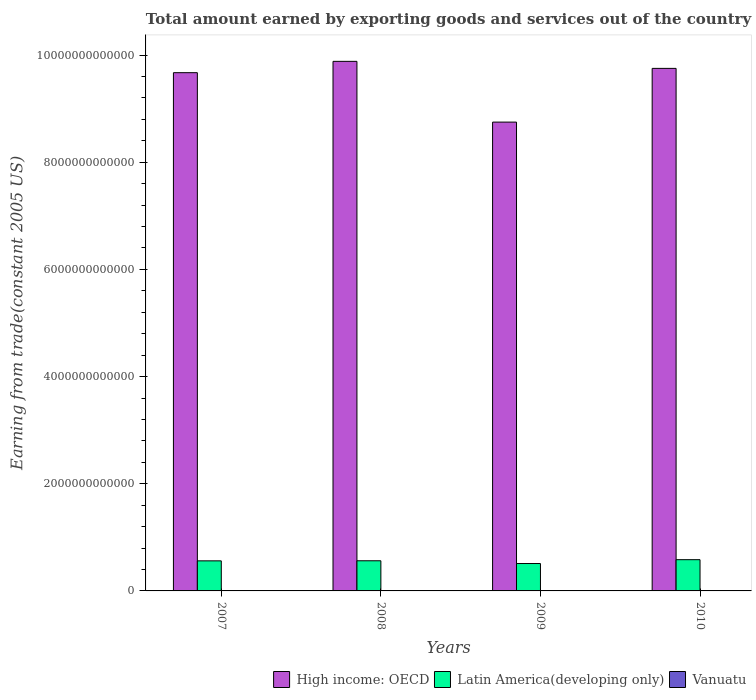How many different coloured bars are there?
Keep it short and to the point. 3. How many groups of bars are there?
Offer a very short reply. 4. Are the number of bars on each tick of the X-axis equal?
Give a very brief answer. Yes. How many bars are there on the 3rd tick from the right?
Provide a succinct answer. 3. What is the total amount earned by exporting goods and services in High income: OECD in 2007?
Offer a terse response. 9.67e+12. Across all years, what is the maximum total amount earned by exporting goods and services in Latin America(developing only)?
Ensure brevity in your answer.  5.83e+11. Across all years, what is the minimum total amount earned by exporting goods and services in High income: OECD?
Offer a very short reply. 8.75e+12. In which year was the total amount earned by exporting goods and services in High income: OECD minimum?
Your answer should be very brief. 2009. What is the total total amount earned by exporting goods and services in Latin America(developing only) in the graph?
Offer a very short reply. 2.22e+12. What is the difference between the total amount earned by exporting goods and services in High income: OECD in 2007 and that in 2008?
Your answer should be compact. -2.11e+11. What is the difference between the total amount earned by exporting goods and services in Latin America(developing only) in 2008 and the total amount earned by exporting goods and services in Vanuatu in 2010?
Offer a very short reply. 5.62e+11. What is the average total amount earned by exporting goods and services in Latin America(developing only) per year?
Keep it short and to the point. 5.55e+11. In the year 2007, what is the difference between the total amount earned by exporting goods and services in Vanuatu and total amount earned by exporting goods and services in Latin America(developing only)?
Your response must be concise. -5.61e+11. In how many years, is the total amount earned by exporting goods and services in Latin America(developing only) greater than 9600000000000 US$?
Offer a terse response. 0. What is the ratio of the total amount earned by exporting goods and services in High income: OECD in 2007 to that in 2008?
Provide a succinct answer. 0.98. What is the difference between the highest and the second highest total amount earned by exporting goods and services in Vanuatu?
Your answer should be compact. 9.76e+05. What is the difference between the highest and the lowest total amount earned by exporting goods and services in Vanuatu?
Your response must be concise. 4.71e+07. Is the sum of the total amount earned by exporting goods and services in Vanuatu in 2008 and 2010 greater than the maximum total amount earned by exporting goods and services in High income: OECD across all years?
Your answer should be very brief. No. What does the 3rd bar from the left in 2009 represents?
Your answer should be very brief. Vanuatu. What does the 2nd bar from the right in 2010 represents?
Your answer should be very brief. Latin America(developing only). Are all the bars in the graph horizontal?
Keep it short and to the point. No. What is the difference between two consecutive major ticks on the Y-axis?
Make the answer very short. 2.00e+12. Are the values on the major ticks of Y-axis written in scientific E-notation?
Your response must be concise. No. Does the graph contain any zero values?
Your answer should be compact. No. Does the graph contain grids?
Offer a very short reply. No. Where does the legend appear in the graph?
Make the answer very short. Bottom right. How many legend labels are there?
Offer a very short reply. 3. What is the title of the graph?
Ensure brevity in your answer.  Total amount earned by exporting goods and services out of the country. What is the label or title of the Y-axis?
Ensure brevity in your answer.  Earning from trade(constant 2005 US). What is the Earning from trade(constant 2005 US) of High income: OECD in 2007?
Keep it short and to the point. 9.67e+12. What is the Earning from trade(constant 2005 US) of Latin America(developing only) in 2007?
Offer a terse response. 5.61e+11. What is the Earning from trade(constant 2005 US) in Vanuatu in 2007?
Give a very brief answer. 1.90e+08. What is the Earning from trade(constant 2005 US) in High income: OECD in 2008?
Provide a succinct answer. 9.88e+12. What is the Earning from trade(constant 2005 US) of Latin America(developing only) in 2008?
Give a very brief answer. 5.63e+11. What is the Earning from trade(constant 2005 US) of Vanuatu in 2008?
Provide a short and direct response. 2.06e+08. What is the Earning from trade(constant 2005 US) in High income: OECD in 2009?
Your answer should be very brief. 8.75e+12. What is the Earning from trade(constant 2005 US) of Latin America(developing only) in 2009?
Offer a very short reply. 5.11e+11. What is the Earning from trade(constant 2005 US) of Vanuatu in 2009?
Your answer should be compact. 2.36e+08. What is the Earning from trade(constant 2005 US) in High income: OECD in 2010?
Keep it short and to the point. 9.75e+12. What is the Earning from trade(constant 2005 US) in Latin America(developing only) in 2010?
Give a very brief answer. 5.83e+11. What is the Earning from trade(constant 2005 US) of Vanuatu in 2010?
Give a very brief answer. 2.37e+08. Across all years, what is the maximum Earning from trade(constant 2005 US) of High income: OECD?
Your response must be concise. 9.88e+12. Across all years, what is the maximum Earning from trade(constant 2005 US) in Latin America(developing only)?
Give a very brief answer. 5.83e+11. Across all years, what is the maximum Earning from trade(constant 2005 US) of Vanuatu?
Provide a short and direct response. 2.37e+08. Across all years, what is the minimum Earning from trade(constant 2005 US) of High income: OECD?
Keep it short and to the point. 8.75e+12. Across all years, what is the minimum Earning from trade(constant 2005 US) of Latin America(developing only)?
Make the answer very short. 5.11e+11. Across all years, what is the minimum Earning from trade(constant 2005 US) of Vanuatu?
Provide a succinct answer. 1.90e+08. What is the total Earning from trade(constant 2005 US) of High income: OECD in the graph?
Your response must be concise. 3.81e+13. What is the total Earning from trade(constant 2005 US) of Latin America(developing only) in the graph?
Provide a succinct answer. 2.22e+12. What is the total Earning from trade(constant 2005 US) in Vanuatu in the graph?
Offer a very short reply. 8.70e+08. What is the difference between the Earning from trade(constant 2005 US) in High income: OECD in 2007 and that in 2008?
Make the answer very short. -2.11e+11. What is the difference between the Earning from trade(constant 2005 US) in Latin America(developing only) in 2007 and that in 2008?
Your answer should be very brief. -1.30e+09. What is the difference between the Earning from trade(constant 2005 US) of Vanuatu in 2007 and that in 2008?
Offer a very short reply. -1.64e+07. What is the difference between the Earning from trade(constant 2005 US) in High income: OECD in 2007 and that in 2009?
Give a very brief answer. 9.22e+11. What is the difference between the Earning from trade(constant 2005 US) of Latin America(developing only) in 2007 and that in 2009?
Offer a very short reply. 5.00e+1. What is the difference between the Earning from trade(constant 2005 US) of Vanuatu in 2007 and that in 2009?
Offer a very short reply. -4.61e+07. What is the difference between the Earning from trade(constant 2005 US) of High income: OECD in 2007 and that in 2010?
Keep it short and to the point. -8.01e+1. What is the difference between the Earning from trade(constant 2005 US) of Latin America(developing only) in 2007 and that in 2010?
Your response must be concise. -2.17e+1. What is the difference between the Earning from trade(constant 2005 US) in Vanuatu in 2007 and that in 2010?
Keep it short and to the point. -4.71e+07. What is the difference between the Earning from trade(constant 2005 US) of High income: OECD in 2008 and that in 2009?
Your answer should be very brief. 1.13e+12. What is the difference between the Earning from trade(constant 2005 US) of Latin America(developing only) in 2008 and that in 2009?
Ensure brevity in your answer.  5.13e+1. What is the difference between the Earning from trade(constant 2005 US) in Vanuatu in 2008 and that in 2009?
Provide a short and direct response. -2.98e+07. What is the difference between the Earning from trade(constant 2005 US) of High income: OECD in 2008 and that in 2010?
Your answer should be very brief. 1.31e+11. What is the difference between the Earning from trade(constant 2005 US) in Latin America(developing only) in 2008 and that in 2010?
Your response must be concise. -2.04e+1. What is the difference between the Earning from trade(constant 2005 US) of Vanuatu in 2008 and that in 2010?
Provide a succinct answer. -3.07e+07. What is the difference between the Earning from trade(constant 2005 US) in High income: OECD in 2009 and that in 2010?
Keep it short and to the point. -1.00e+12. What is the difference between the Earning from trade(constant 2005 US) in Latin America(developing only) in 2009 and that in 2010?
Offer a terse response. -7.18e+1. What is the difference between the Earning from trade(constant 2005 US) in Vanuatu in 2009 and that in 2010?
Offer a very short reply. -9.76e+05. What is the difference between the Earning from trade(constant 2005 US) of High income: OECD in 2007 and the Earning from trade(constant 2005 US) of Latin America(developing only) in 2008?
Keep it short and to the point. 9.11e+12. What is the difference between the Earning from trade(constant 2005 US) of High income: OECD in 2007 and the Earning from trade(constant 2005 US) of Vanuatu in 2008?
Your answer should be compact. 9.67e+12. What is the difference between the Earning from trade(constant 2005 US) in Latin America(developing only) in 2007 and the Earning from trade(constant 2005 US) in Vanuatu in 2008?
Provide a succinct answer. 5.61e+11. What is the difference between the Earning from trade(constant 2005 US) of High income: OECD in 2007 and the Earning from trade(constant 2005 US) of Latin America(developing only) in 2009?
Offer a terse response. 9.16e+12. What is the difference between the Earning from trade(constant 2005 US) in High income: OECD in 2007 and the Earning from trade(constant 2005 US) in Vanuatu in 2009?
Your answer should be very brief. 9.67e+12. What is the difference between the Earning from trade(constant 2005 US) of Latin America(developing only) in 2007 and the Earning from trade(constant 2005 US) of Vanuatu in 2009?
Offer a terse response. 5.61e+11. What is the difference between the Earning from trade(constant 2005 US) of High income: OECD in 2007 and the Earning from trade(constant 2005 US) of Latin America(developing only) in 2010?
Provide a succinct answer. 9.09e+12. What is the difference between the Earning from trade(constant 2005 US) of High income: OECD in 2007 and the Earning from trade(constant 2005 US) of Vanuatu in 2010?
Offer a terse response. 9.67e+12. What is the difference between the Earning from trade(constant 2005 US) of Latin America(developing only) in 2007 and the Earning from trade(constant 2005 US) of Vanuatu in 2010?
Your answer should be very brief. 5.61e+11. What is the difference between the Earning from trade(constant 2005 US) of High income: OECD in 2008 and the Earning from trade(constant 2005 US) of Latin America(developing only) in 2009?
Your answer should be compact. 9.37e+12. What is the difference between the Earning from trade(constant 2005 US) of High income: OECD in 2008 and the Earning from trade(constant 2005 US) of Vanuatu in 2009?
Provide a succinct answer. 9.88e+12. What is the difference between the Earning from trade(constant 2005 US) of Latin America(developing only) in 2008 and the Earning from trade(constant 2005 US) of Vanuatu in 2009?
Your response must be concise. 5.62e+11. What is the difference between the Earning from trade(constant 2005 US) of High income: OECD in 2008 and the Earning from trade(constant 2005 US) of Latin America(developing only) in 2010?
Ensure brevity in your answer.  9.30e+12. What is the difference between the Earning from trade(constant 2005 US) of High income: OECD in 2008 and the Earning from trade(constant 2005 US) of Vanuatu in 2010?
Provide a succinct answer. 9.88e+12. What is the difference between the Earning from trade(constant 2005 US) of Latin America(developing only) in 2008 and the Earning from trade(constant 2005 US) of Vanuatu in 2010?
Your answer should be compact. 5.62e+11. What is the difference between the Earning from trade(constant 2005 US) in High income: OECD in 2009 and the Earning from trade(constant 2005 US) in Latin America(developing only) in 2010?
Your answer should be compact. 8.17e+12. What is the difference between the Earning from trade(constant 2005 US) in High income: OECD in 2009 and the Earning from trade(constant 2005 US) in Vanuatu in 2010?
Keep it short and to the point. 8.75e+12. What is the difference between the Earning from trade(constant 2005 US) of Latin America(developing only) in 2009 and the Earning from trade(constant 2005 US) of Vanuatu in 2010?
Keep it short and to the point. 5.11e+11. What is the average Earning from trade(constant 2005 US) of High income: OECD per year?
Your response must be concise. 9.51e+12. What is the average Earning from trade(constant 2005 US) of Latin America(developing only) per year?
Your answer should be compact. 5.55e+11. What is the average Earning from trade(constant 2005 US) in Vanuatu per year?
Provide a short and direct response. 2.18e+08. In the year 2007, what is the difference between the Earning from trade(constant 2005 US) in High income: OECD and Earning from trade(constant 2005 US) in Latin America(developing only)?
Make the answer very short. 9.11e+12. In the year 2007, what is the difference between the Earning from trade(constant 2005 US) of High income: OECD and Earning from trade(constant 2005 US) of Vanuatu?
Keep it short and to the point. 9.67e+12. In the year 2007, what is the difference between the Earning from trade(constant 2005 US) in Latin America(developing only) and Earning from trade(constant 2005 US) in Vanuatu?
Provide a short and direct response. 5.61e+11. In the year 2008, what is the difference between the Earning from trade(constant 2005 US) in High income: OECD and Earning from trade(constant 2005 US) in Latin America(developing only)?
Make the answer very short. 9.32e+12. In the year 2008, what is the difference between the Earning from trade(constant 2005 US) of High income: OECD and Earning from trade(constant 2005 US) of Vanuatu?
Ensure brevity in your answer.  9.88e+12. In the year 2008, what is the difference between the Earning from trade(constant 2005 US) in Latin America(developing only) and Earning from trade(constant 2005 US) in Vanuatu?
Make the answer very short. 5.62e+11. In the year 2009, what is the difference between the Earning from trade(constant 2005 US) of High income: OECD and Earning from trade(constant 2005 US) of Latin America(developing only)?
Keep it short and to the point. 8.24e+12. In the year 2009, what is the difference between the Earning from trade(constant 2005 US) in High income: OECD and Earning from trade(constant 2005 US) in Vanuatu?
Keep it short and to the point. 8.75e+12. In the year 2009, what is the difference between the Earning from trade(constant 2005 US) in Latin America(developing only) and Earning from trade(constant 2005 US) in Vanuatu?
Offer a terse response. 5.11e+11. In the year 2010, what is the difference between the Earning from trade(constant 2005 US) in High income: OECD and Earning from trade(constant 2005 US) in Latin America(developing only)?
Ensure brevity in your answer.  9.17e+12. In the year 2010, what is the difference between the Earning from trade(constant 2005 US) in High income: OECD and Earning from trade(constant 2005 US) in Vanuatu?
Ensure brevity in your answer.  9.75e+12. In the year 2010, what is the difference between the Earning from trade(constant 2005 US) in Latin America(developing only) and Earning from trade(constant 2005 US) in Vanuatu?
Ensure brevity in your answer.  5.83e+11. What is the ratio of the Earning from trade(constant 2005 US) of High income: OECD in 2007 to that in 2008?
Your response must be concise. 0.98. What is the ratio of the Earning from trade(constant 2005 US) of Latin America(developing only) in 2007 to that in 2008?
Provide a short and direct response. 1. What is the ratio of the Earning from trade(constant 2005 US) in Vanuatu in 2007 to that in 2008?
Offer a terse response. 0.92. What is the ratio of the Earning from trade(constant 2005 US) of High income: OECD in 2007 to that in 2009?
Offer a terse response. 1.11. What is the ratio of the Earning from trade(constant 2005 US) in Latin America(developing only) in 2007 to that in 2009?
Keep it short and to the point. 1.1. What is the ratio of the Earning from trade(constant 2005 US) in Vanuatu in 2007 to that in 2009?
Make the answer very short. 0.8. What is the ratio of the Earning from trade(constant 2005 US) of Latin America(developing only) in 2007 to that in 2010?
Keep it short and to the point. 0.96. What is the ratio of the Earning from trade(constant 2005 US) of Vanuatu in 2007 to that in 2010?
Offer a very short reply. 0.8. What is the ratio of the Earning from trade(constant 2005 US) of High income: OECD in 2008 to that in 2009?
Your answer should be very brief. 1.13. What is the ratio of the Earning from trade(constant 2005 US) of Latin America(developing only) in 2008 to that in 2009?
Offer a terse response. 1.1. What is the ratio of the Earning from trade(constant 2005 US) in Vanuatu in 2008 to that in 2009?
Provide a succinct answer. 0.87. What is the ratio of the Earning from trade(constant 2005 US) of High income: OECD in 2008 to that in 2010?
Your response must be concise. 1.01. What is the ratio of the Earning from trade(constant 2005 US) of Latin America(developing only) in 2008 to that in 2010?
Make the answer very short. 0.96. What is the ratio of the Earning from trade(constant 2005 US) in Vanuatu in 2008 to that in 2010?
Make the answer very short. 0.87. What is the ratio of the Earning from trade(constant 2005 US) in High income: OECD in 2009 to that in 2010?
Offer a very short reply. 0.9. What is the ratio of the Earning from trade(constant 2005 US) in Latin America(developing only) in 2009 to that in 2010?
Provide a short and direct response. 0.88. What is the ratio of the Earning from trade(constant 2005 US) in Vanuatu in 2009 to that in 2010?
Offer a very short reply. 1. What is the difference between the highest and the second highest Earning from trade(constant 2005 US) of High income: OECD?
Give a very brief answer. 1.31e+11. What is the difference between the highest and the second highest Earning from trade(constant 2005 US) of Latin America(developing only)?
Your response must be concise. 2.04e+1. What is the difference between the highest and the second highest Earning from trade(constant 2005 US) in Vanuatu?
Ensure brevity in your answer.  9.76e+05. What is the difference between the highest and the lowest Earning from trade(constant 2005 US) in High income: OECD?
Provide a short and direct response. 1.13e+12. What is the difference between the highest and the lowest Earning from trade(constant 2005 US) of Latin America(developing only)?
Your response must be concise. 7.18e+1. What is the difference between the highest and the lowest Earning from trade(constant 2005 US) of Vanuatu?
Provide a succinct answer. 4.71e+07. 